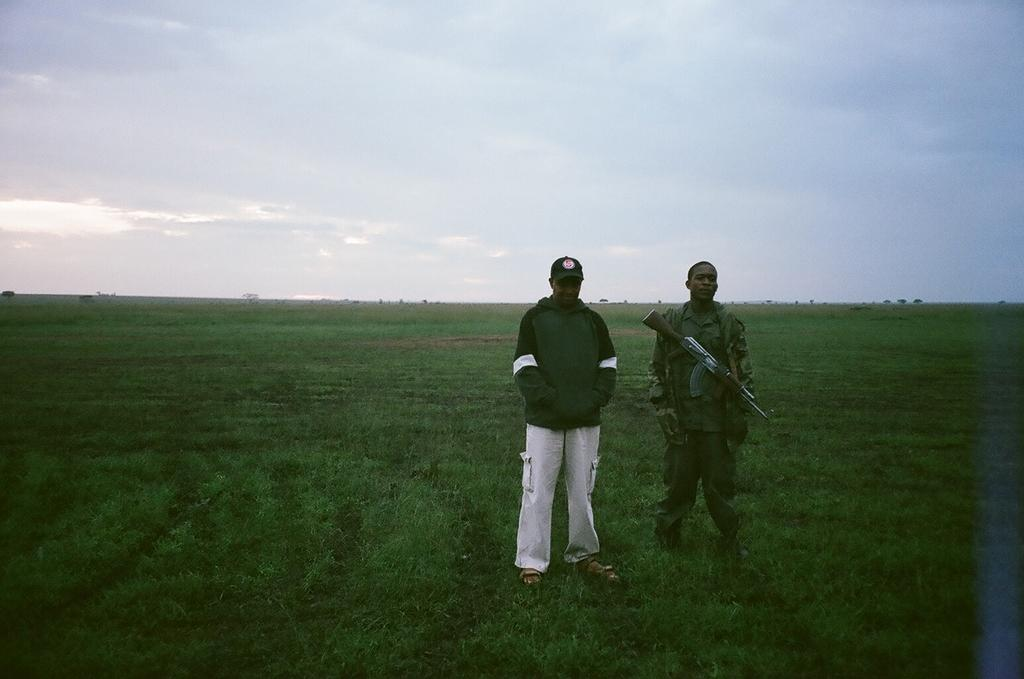What is happening in the image? There are people on the ground in the image. Can you describe the attire of one of the individuals? One person is wearing a uniform. What is the person in the uniform holding? The person in the uniform is holding a gun. What type of headwear is worn by another person in the image? Another person is wearing a cap. What is visible at the top of the image? The sky is visible at the top of the image. What type of bird can be seen in the image? There is no bird present in the image; it features people on the ground. What kind of group is depicted in the image? The image does not depict a specific group; it simply shows people on the ground. 